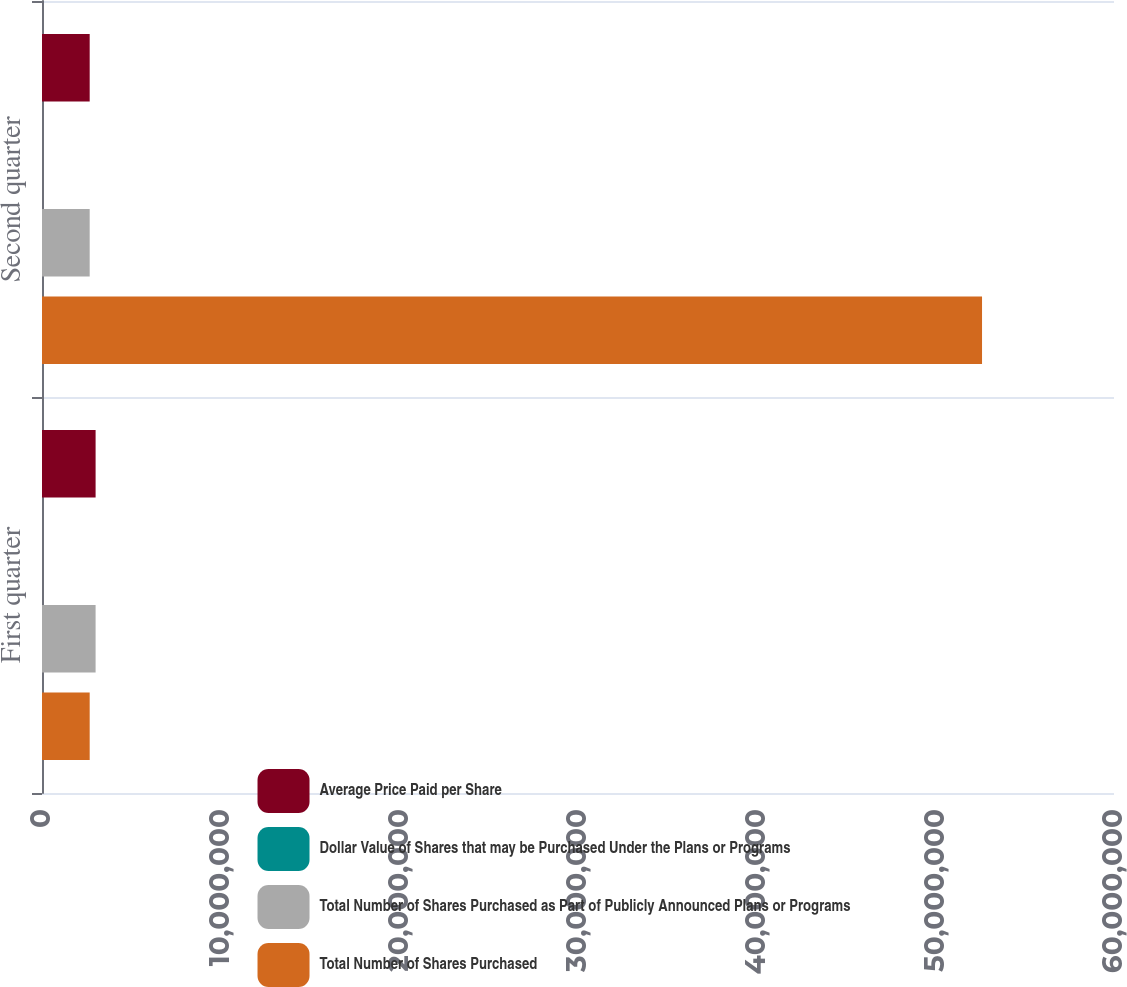Convert chart to OTSL. <chart><loc_0><loc_0><loc_500><loc_500><stacked_bar_chart><ecel><fcel>First quarter<fcel>Second quarter<nl><fcel>Average Price Paid per Share<fcel>3e+06<fcel>2.6692e+06<nl><fcel>Dollar Value of Shares that may be Purchased Under the Plans or Programs<fcel>34.38<fcel>42.16<nl><fcel>Total Number of Shares Purchased as Part of Publicly Announced Plans or Programs<fcel>3e+06<fcel>2.6692e+06<nl><fcel>Total Number of Shares Purchased<fcel>2.6692e+06<fcel>5.26139e+07<nl></chart> 